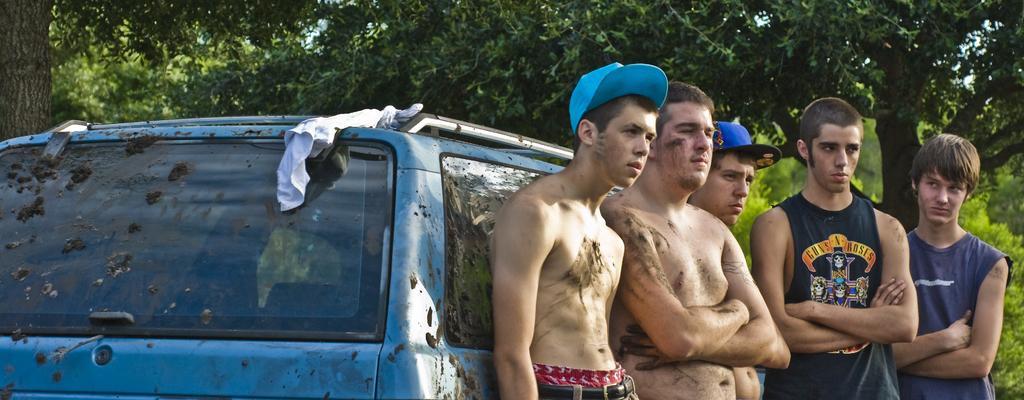How would you summarize this image in a sentence or two? In this image we can see people standing beside a car. In the background of the image there are trees. 